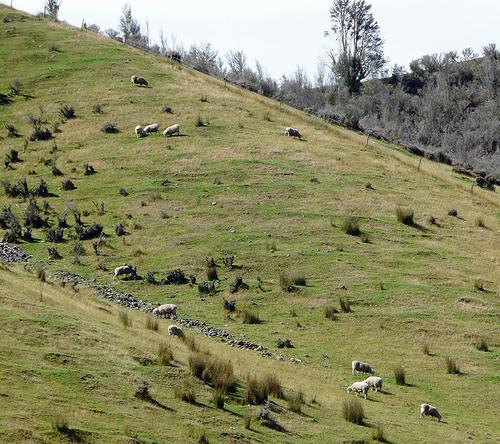Question: what animal is on the hill?
Choices:
A. Deer.
B. Sheep.
C. Bear.
D. A bird.
Answer with the letter. Answer: B Question: when was this picture taken?
Choices:
A. During the day.
B. Sunset.
C. At night.
D. Sunrise.
Answer with the letter. Answer: A Question: what are the sheep eating?
Choices:
A. Grass.
B. Sticks.
C. Grain.
D. Wool.
Answer with the letter. Answer: A Question: what is growing in the background?
Choices:
A. Roses.
B. Weeds.
C. The water level.
D. Trees.
Answer with the letter. Answer: D Question: where was this photo taken?
Choices:
A. On a beach.
B. On a football field.
C. At a church.
D. On a hillside.
Answer with the letter. Answer: D 